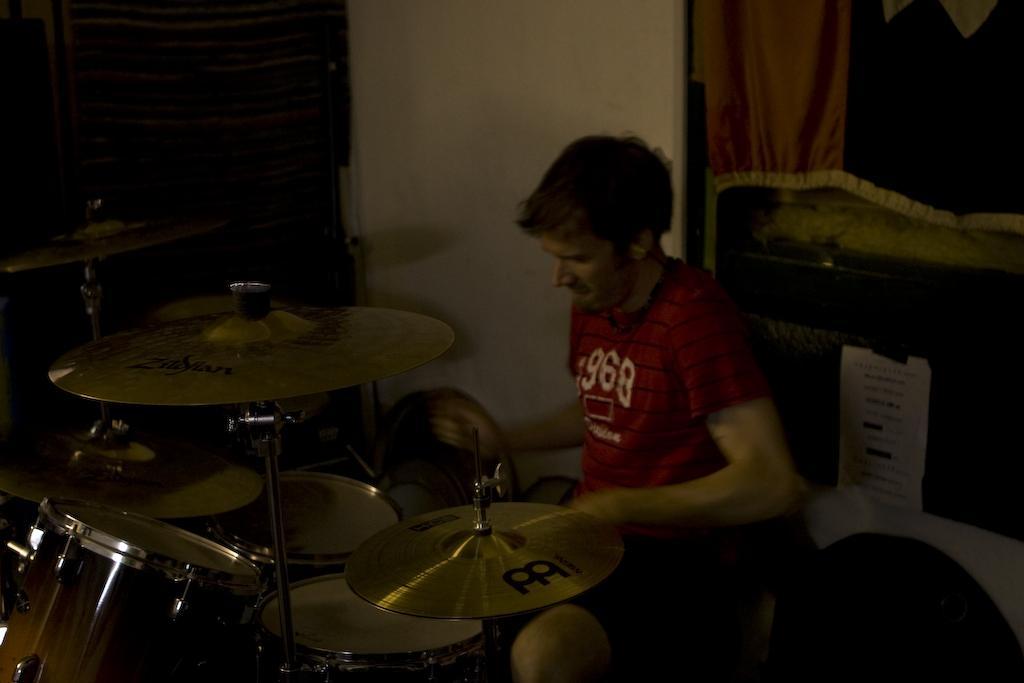In one or two sentences, can you explain what this image depicts? In this picture, I can see a man seated and playing drums and we can see a cloth to the window and a paper. 